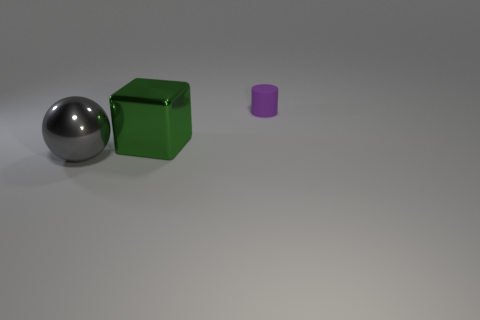There is a metallic thing in front of the large green object; what color is it?
Give a very brief answer. Gray. How many other things are the same color as the cube?
Ensure brevity in your answer.  0. There is a object that is to the left of the block; does it have the same size as the tiny cylinder?
Provide a succinct answer. No. What number of matte things are in front of the cylinder?
Provide a succinct answer. 0. Is there a metal sphere of the same size as the green metal object?
Your answer should be compact. Yes. Is the color of the matte cylinder the same as the large ball?
Your response must be concise. No. What color is the big ball that is in front of the large metallic object that is behind the large gray sphere?
Your answer should be very brief. Gray. How many objects are behind the large green object and left of the rubber object?
Offer a very short reply. 0. What number of other objects are the same shape as the gray metal object?
Your answer should be compact. 0. Is the cylinder made of the same material as the big gray sphere?
Give a very brief answer. No. 